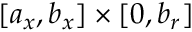Convert formula to latex. <formula><loc_0><loc_0><loc_500><loc_500>[ a _ { x } , b _ { x } ] \times [ 0 , b _ { r } ]</formula> 